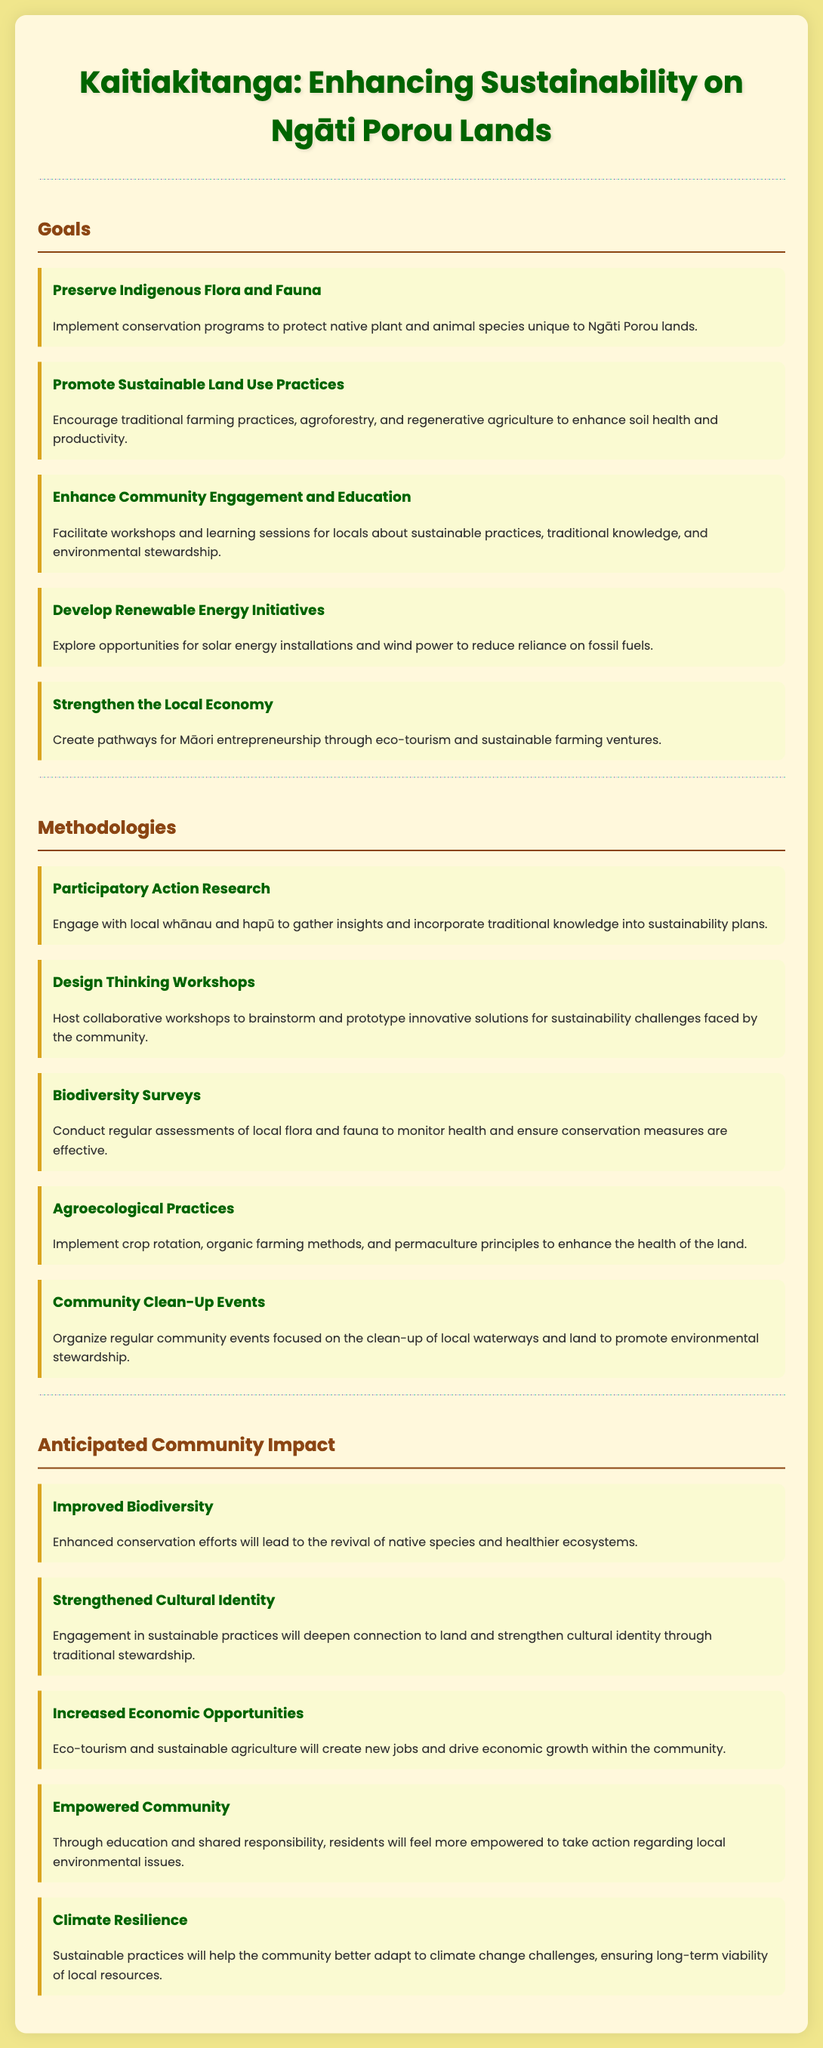What are the goals of the sustainability project? The goals are listed in the document and encompass topics like conservation and community engagement.
Answer: Preserving Indigenous Flora and Fauna, Promoting Sustainable Land Use Practices, Enhancing Community Engagement and Education, Developing Renewable Energy Initiatives, Strengthening the Local Economy How many methodologies are proposed in the document? The document details various methodologies used for the sustainability project, specifically outlining several methods.
Answer: Five What is the first goal mentioned in the document? The document lists goals in a specific order; the first one is related to conservation efforts.
Answer: Preserve Indigenous Flora and Fauna What type of community engagement activities are included as methodologies? Activities to engage the community are mentioned; they focus on education and direct involvement.
Answer: Design Thinking Workshops, Community Clean-Up Events What is the anticipated community impact regarding biodiversity? The anticipated benefit for biodiversity is highlighted in one of the impact sections of the document.
Answer: Improved Biodiversity What is a primary focus of the sustainability project? A primary focus is highlighted within the goals section, specifically about traditional knowledge and land practices.
Answer: Traditional farming practices, agroforestry, and regenerative agriculture Which methodology involves collaboration with local whānau and hapū? One methodology emphasizes engaging with local communities to infuse traditional knowledge into practices.
Answer: Participatory Action Research What outcome is expected from the development of eco-tourism? The document indicates that eco-tourism will drive economic improvement within the community.
Answer: Increased Economic Opportunities 